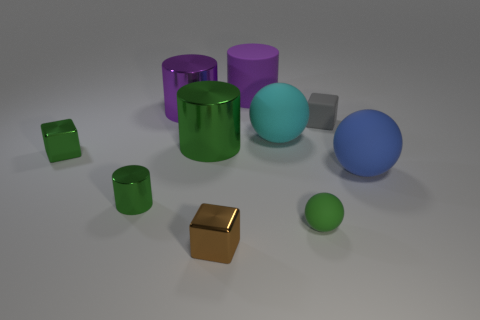How big is the thing that is both behind the large green cylinder and to the left of the big green cylinder?
Offer a very short reply. Large. How many metallic things are green blocks or purple cylinders?
Offer a terse response. 2. Is the number of rubber objects that are right of the big purple rubber cylinder greater than the number of tiny green things?
Make the answer very short. Yes. There is a small block behind the green cube; what is its material?
Offer a terse response. Rubber. What number of small green things have the same material as the large blue thing?
Your response must be concise. 1. The tiny green thing that is both in front of the large blue sphere and left of the matte cylinder has what shape?
Your answer should be compact. Cylinder. How many objects are things behind the small rubber block or large rubber objects left of the tiny gray thing?
Offer a very short reply. 3. Are there an equal number of big cyan spheres that are in front of the cyan thing and tiny brown metallic cubes that are left of the purple shiny cylinder?
Provide a succinct answer. Yes. There is a tiny green thing on the right side of the metal cube right of the small cylinder; what is its shape?
Give a very brief answer. Sphere. Are there any green rubber things that have the same shape as the blue thing?
Keep it short and to the point. Yes. 